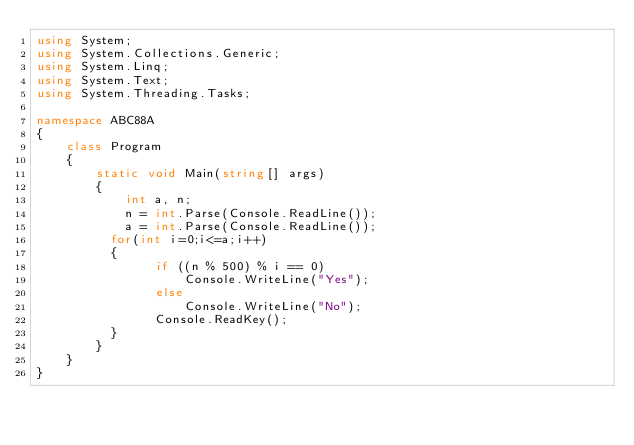<code> <loc_0><loc_0><loc_500><loc_500><_C#_>using System;
using System.Collections.Generic;
using System.Linq;
using System.Text;
using System.Threading.Tasks;

namespace ABC88A
{
    class Program
    {
        static void Main(string[] args)
        {
            int a, n;
            n = int.Parse(Console.ReadLine());
            a = int.Parse(Console.ReadLine());
          for(int i=0;i<=a;i++)
          {
                if ((n % 500) % i == 0)
                    Console.WriteLine("Yes");
                else
                    Console.WriteLine("No");
                Console.ReadKey();
          }
        }
    }
}
</code> 